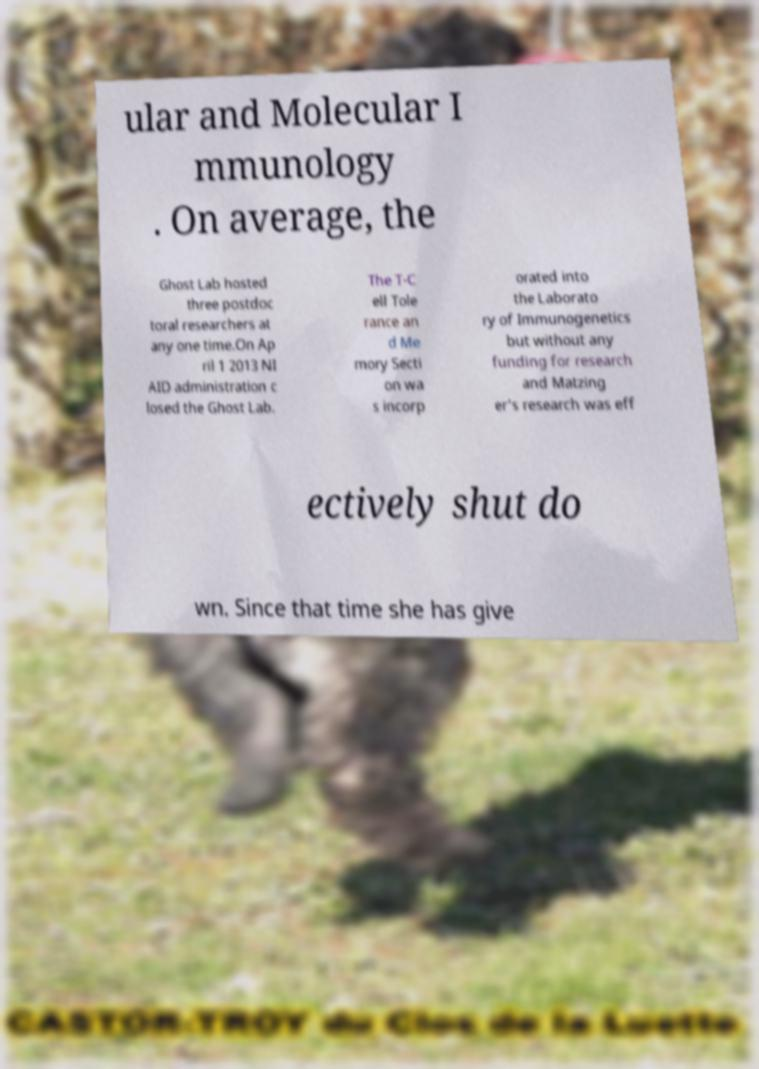Can you read and provide the text displayed in the image?This photo seems to have some interesting text. Can you extract and type it out for me? ular and Molecular I mmunology . On average, the Ghost Lab hosted three postdoc toral researchers at any one time.On Ap ril 1 2013 NI AID administration c losed the Ghost Lab. The T-C ell Tole rance an d Me mory Secti on wa s incorp orated into the Laborato ry of Immunogenetics but without any funding for research and Matzing er's research was eff ectively shut do wn. Since that time she has give 